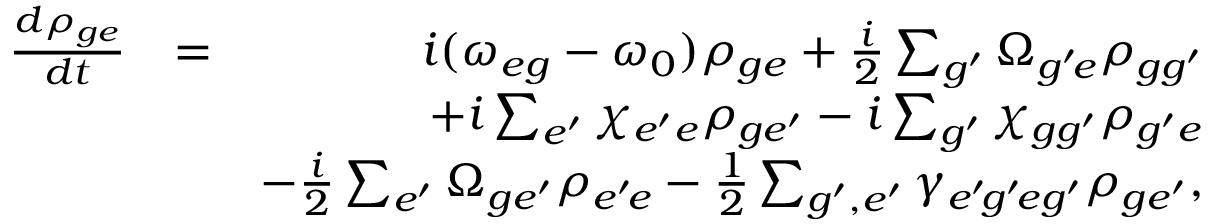Convert formula to latex. <formula><loc_0><loc_0><loc_500><loc_500>\begin{array} { r l r } { \frac { d \rho _ { g e } } { d t } } & { = } & { i ( \omega _ { e g } - \omega _ { 0 } ) \rho _ { g e } + \frac { i } { 2 } \sum _ { g ^ { \prime } } \Omega _ { g ^ { \prime } \, e } \rho _ { g g ^ { \prime } } } \\ & { + i \sum _ { e ^ { \prime } } \chi _ { e ^ { \prime } e } \rho _ { g e ^ { \prime } } - i \sum _ { g ^ { \prime } } \chi _ { g g ^ { \prime } } \rho _ { g ^ { \prime } e } } \\ & { - \frac { i } { 2 } \sum _ { e ^ { \prime } } \Omega _ { g e ^ { \prime } } \rho _ { e ^ { \prime } \, e } - \frac { 1 } { 2 } \sum _ { g ^ { \prime } , e ^ { \prime } } \gamma _ { e ^ { \prime } \, g ^ { \prime } \, e g ^ { \prime } } \rho _ { g e ^ { \prime } } , } \end{array}</formula> 